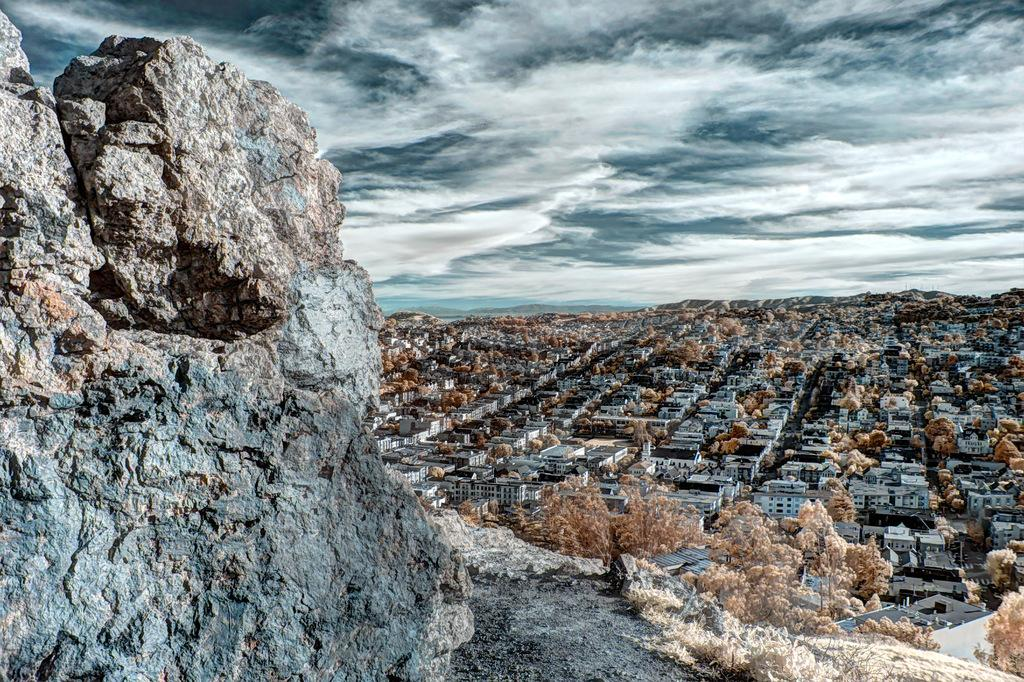What type of geographical feature is in the image? There is a rocky mountain in the image. What is located in front of the mountain? There are buildings and trees in front of the mountain. What can be seen at the top of the image? Clouds are visible at the top of the image. What else is visible in the image? The sky is visible in the image. Can you see the tail of the animal in the image? There is no animal with a tail present in the image. What type of flesh can be seen on the mountain in the image? There is no flesh visible on the mountain in the image; it is a rocky mountain. 